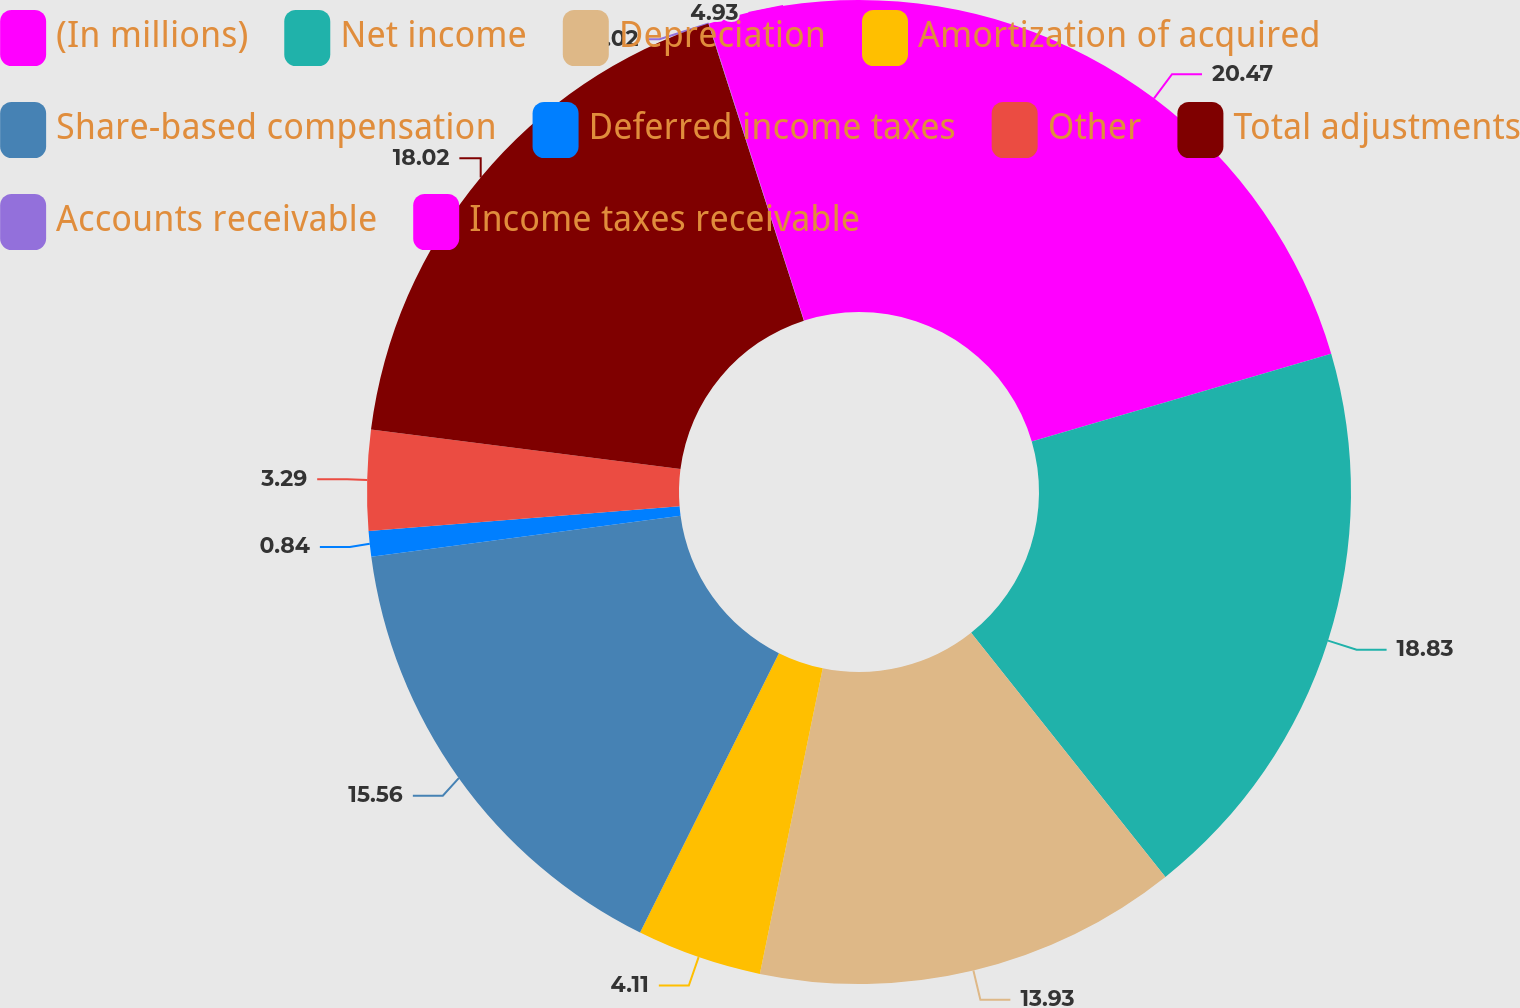Convert chart. <chart><loc_0><loc_0><loc_500><loc_500><pie_chart><fcel>(In millions)<fcel>Net income<fcel>Depreciation<fcel>Amortization of acquired<fcel>Share-based compensation<fcel>Deferred income taxes<fcel>Other<fcel>Total adjustments<fcel>Accounts receivable<fcel>Income taxes receivable<nl><fcel>20.47%<fcel>18.83%<fcel>13.93%<fcel>4.11%<fcel>15.56%<fcel>0.84%<fcel>3.29%<fcel>18.02%<fcel>0.02%<fcel>4.93%<nl></chart> 